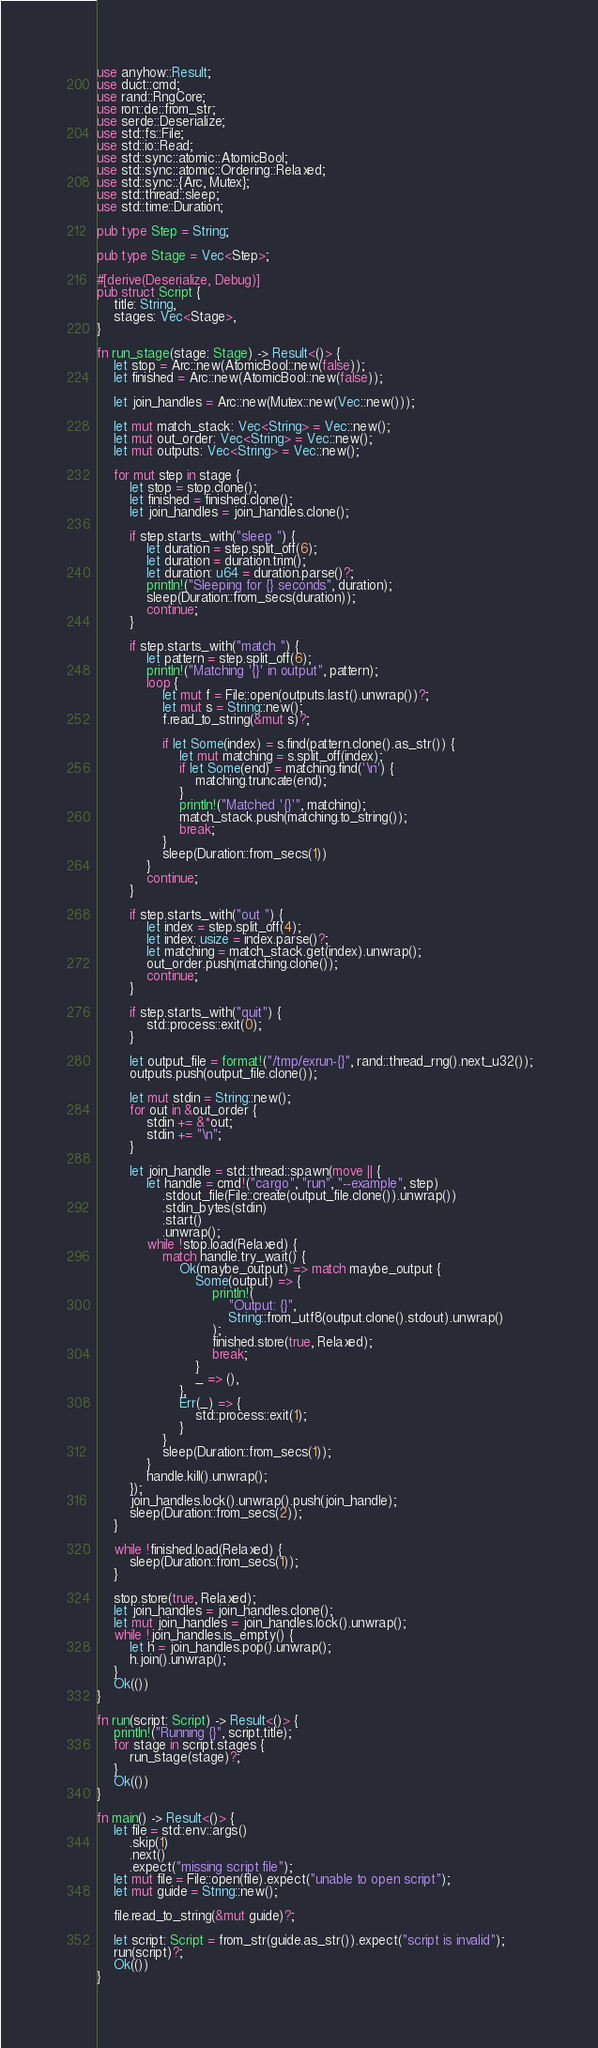Convert code to text. <code><loc_0><loc_0><loc_500><loc_500><_Rust_>use anyhow::Result;
use duct::cmd;
use rand::RngCore;
use ron::de::from_str;
use serde::Deserialize;
use std::fs::File;
use std::io::Read;
use std::sync::atomic::AtomicBool;
use std::sync::atomic::Ordering::Relaxed;
use std::sync::{Arc, Mutex};
use std::thread::sleep;
use std::time::Duration;

pub type Step = String;

pub type Stage = Vec<Step>;

#[derive(Deserialize, Debug)]
pub struct Script {
    title: String,
    stages: Vec<Stage>,
}

fn run_stage(stage: Stage) -> Result<()> {
    let stop = Arc::new(AtomicBool::new(false));
    let finished = Arc::new(AtomicBool::new(false));

    let join_handles = Arc::new(Mutex::new(Vec::new()));

    let mut match_stack: Vec<String> = Vec::new();
    let mut out_order: Vec<String> = Vec::new();
    let mut outputs: Vec<String> = Vec::new();

    for mut step in stage {
        let stop = stop.clone();
        let finished = finished.clone();
        let join_handles = join_handles.clone();

        if step.starts_with("sleep ") {
            let duration = step.split_off(6);
            let duration = duration.trim();
            let duration: u64 = duration.parse()?;
            println!("Sleeping for {} seconds", duration);
            sleep(Duration::from_secs(duration));
            continue;
        }

        if step.starts_with("match ") {
            let pattern = step.split_off(6);
            println!("Matching '{}' in output", pattern);
            loop {
                let mut f = File::open(outputs.last().unwrap())?;
                let mut s = String::new();
                f.read_to_string(&mut s)?;

                if let Some(index) = s.find(pattern.clone().as_str()) {
                    let mut matching = s.split_off(index);
                    if let Some(end) = matching.find('\n') {
                        matching.truncate(end);
                    }
                    println!("Matched '{}'", matching);
                    match_stack.push(matching.to_string());
                    break;
                }
                sleep(Duration::from_secs(1))
            }
            continue;
        }

        if step.starts_with("out ") {
            let index = step.split_off(4);
            let index: usize = index.parse()?;
            let matching = match_stack.get(index).unwrap();
            out_order.push(matching.clone());
            continue;
        }

        if step.starts_with("quit") {
            std::process::exit(0);
        }

        let output_file = format!("/tmp/exrun-{}", rand::thread_rng().next_u32());
        outputs.push(output_file.clone());

        let mut stdin = String::new();
        for out in &out_order {
            stdin += &*out;
            stdin += "\n";
        }

        let join_handle = std::thread::spawn(move || {
            let handle = cmd!("cargo", "run", "--example", step)
                .stdout_file(File::create(output_file.clone()).unwrap())
                .stdin_bytes(stdin)
                .start()
                .unwrap();
            while !stop.load(Relaxed) {
                match handle.try_wait() {
                    Ok(maybe_output) => match maybe_output {
                        Some(output) => {
                            println!(
                                "Output: {}",
                                String::from_utf8(output.clone().stdout).unwrap()
                            );
                            finished.store(true, Relaxed);
                            break;
                        }
                        _ => (),
                    },
                    Err(_) => {
                        std::process::exit(1);
                    }
                }
                sleep(Duration::from_secs(1));
            }
            handle.kill().unwrap();
        });
        join_handles.lock().unwrap().push(join_handle);
        sleep(Duration::from_secs(2));
    }

    while !finished.load(Relaxed) {
        sleep(Duration::from_secs(1));
    }

    stop.store(true, Relaxed);
    let join_handles = join_handles.clone();
    let mut join_handles = join_handles.lock().unwrap();
    while !join_handles.is_empty() {
        let h = join_handles.pop().unwrap();
        h.join().unwrap();
    }
    Ok(())
}

fn run(script: Script) -> Result<()> {
    println!("Running {}", script.title);
    for stage in script.stages {
        run_stage(stage)?;
    }
    Ok(())
}

fn main() -> Result<()> {
    let file = std::env::args()
        .skip(1)
        .next()
        .expect("missing script file");
    let mut file = File::open(file).expect("unable to open script");
    let mut guide = String::new();

    file.read_to_string(&mut guide)?;

    let script: Script = from_str(guide.as_str()).expect("script is invalid");
    run(script)?;
    Ok(())
}
</code> 